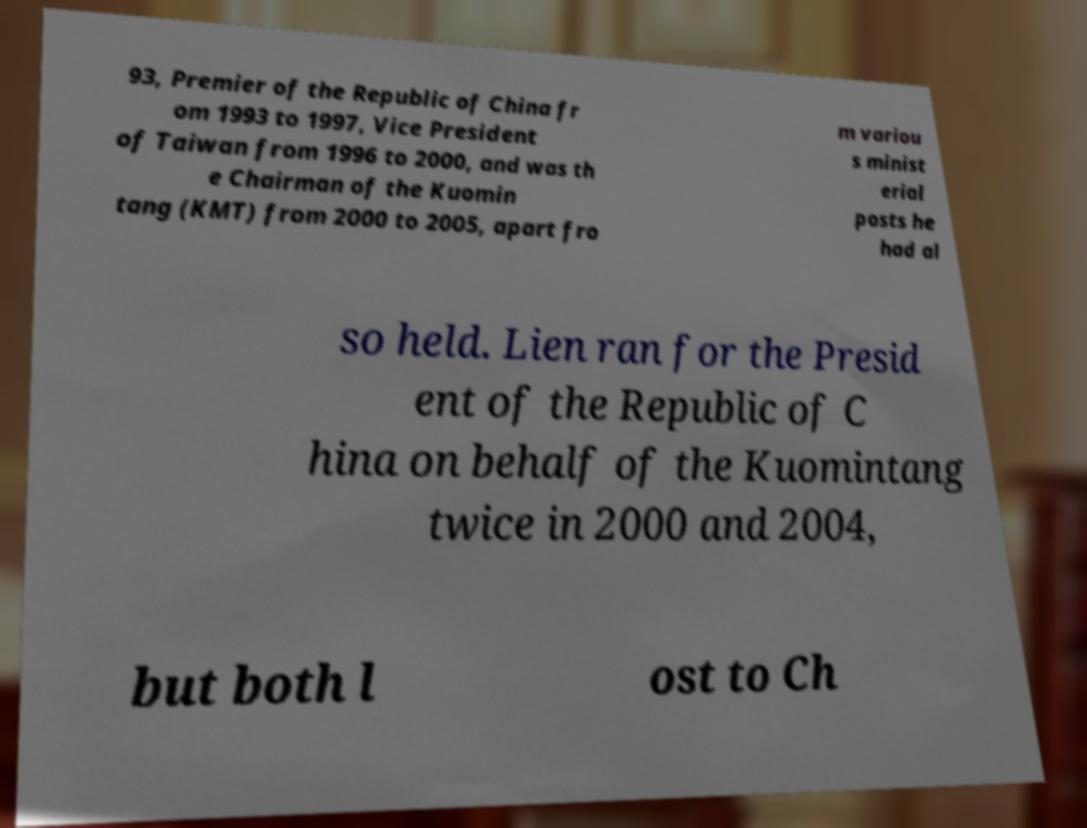I need the written content from this picture converted into text. Can you do that? 93, Premier of the Republic of China fr om 1993 to 1997, Vice President of Taiwan from 1996 to 2000, and was th e Chairman of the Kuomin tang (KMT) from 2000 to 2005, apart fro m variou s minist erial posts he had al so held. Lien ran for the Presid ent of the Republic of C hina on behalf of the Kuomintang twice in 2000 and 2004, but both l ost to Ch 